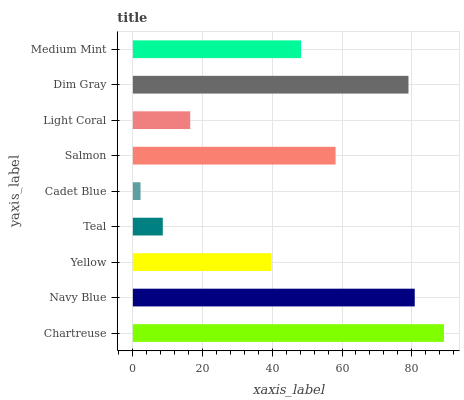Is Cadet Blue the minimum?
Answer yes or no. Yes. Is Chartreuse the maximum?
Answer yes or no. Yes. Is Navy Blue the minimum?
Answer yes or no. No. Is Navy Blue the maximum?
Answer yes or no. No. Is Chartreuse greater than Navy Blue?
Answer yes or no. Yes. Is Navy Blue less than Chartreuse?
Answer yes or no. Yes. Is Navy Blue greater than Chartreuse?
Answer yes or no. No. Is Chartreuse less than Navy Blue?
Answer yes or no. No. Is Medium Mint the high median?
Answer yes or no. Yes. Is Medium Mint the low median?
Answer yes or no. Yes. Is Cadet Blue the high median?
Answer yes or no. No. Is Navy Blue the low median?
Answer yes or no. No. 